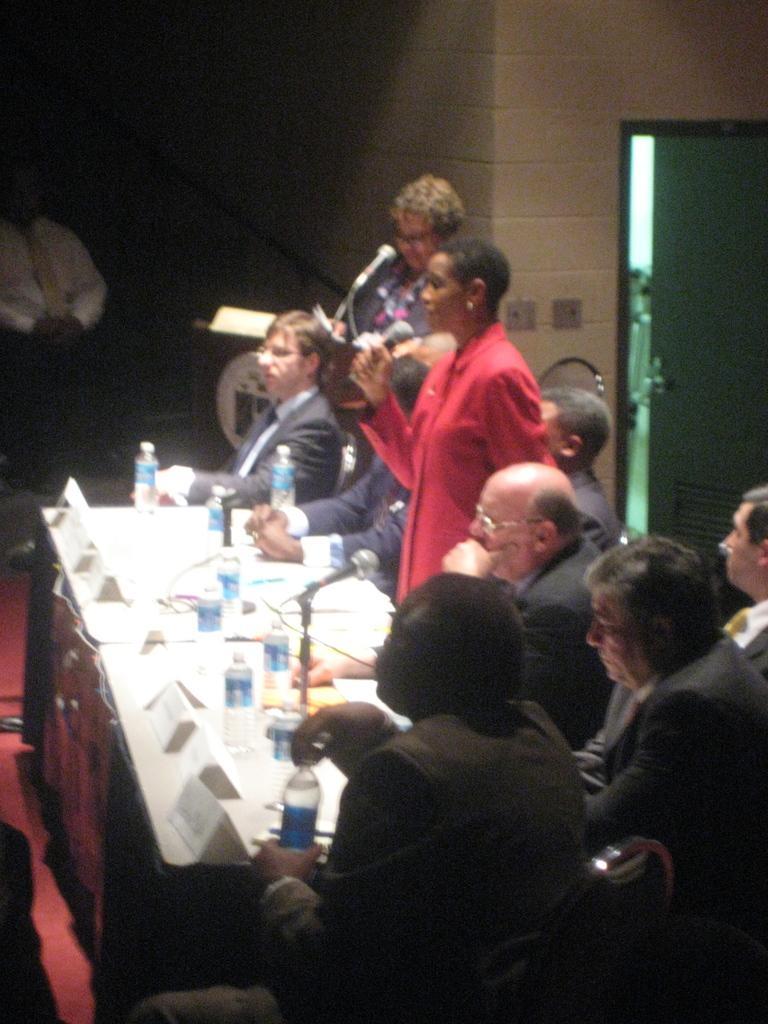Please provide a concise description of this image. In this picture we can see a group of people sitting on the chairs near the tables with bottles, mike's, cards placed on them. We can also see people with a mike standing and looking at someone. In the background, we can see a door. 